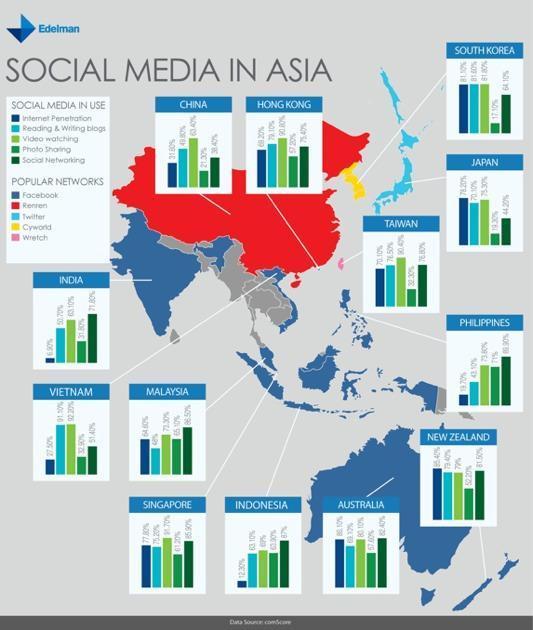Highlight a few significant elements in this photo. Facebook is the most popular network in India. Wretch is popular in Taiwan. Twitter is the most popular social networking platform in Japan. Reading and writing blogs is the second least used social media in Australia. Photo sharing is the second least used social media platform in India. 